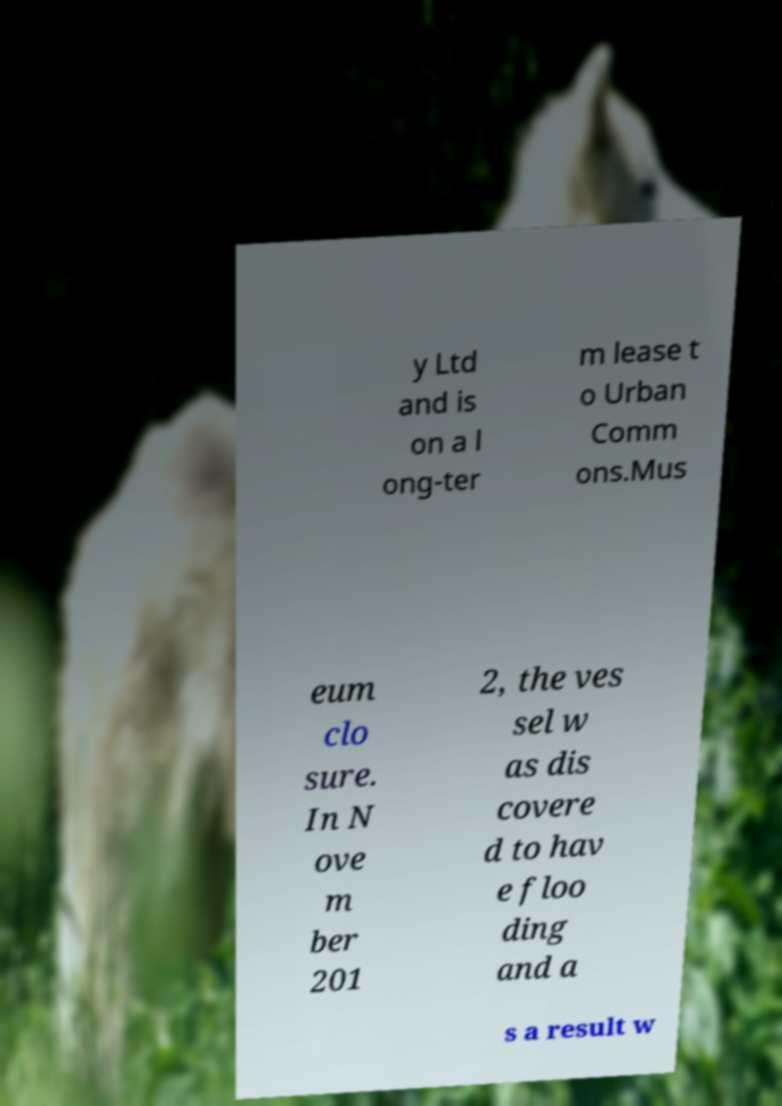What messages or text are displayed in this image? I need them in a readable, typed format. y Ltd and is on a l ong-ter m lease t o Urban Comm ons.Mus eum clo sure. In N ove m ber 201 2, the ves sel w as dis covere d to hav e floo ding and a s a result w 